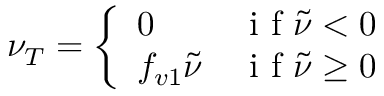Convert formula to latex. <formula><loc_0><loc_0><loc_500><loc_500>\nu _ { T } = \left \{ \begin{array} { l l } { 0 } & { i f \tilde { \nu } < 0 } \\ { f _ { v 1 } \tilde { \nu } } & { i f \tilde { \nu } \geq 0 } \end{array}</formula> 